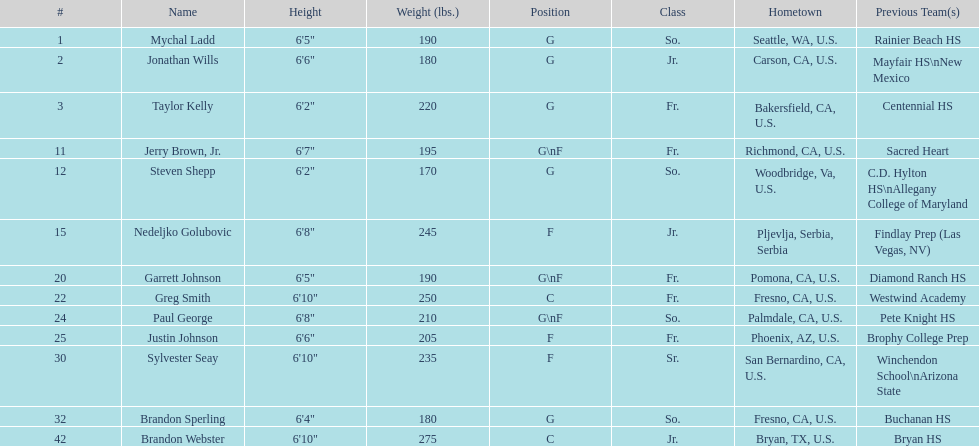Between paul george and greg smith, who has a greater height? Greg Smith. 